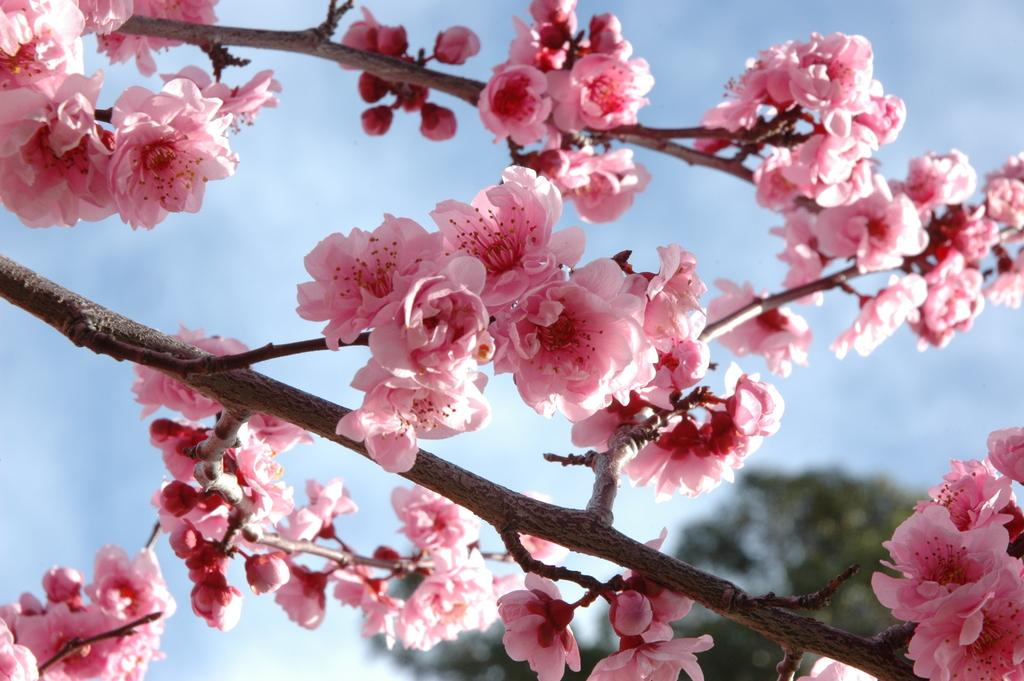What type of plants can be seen in the image? There are flowers in the image. What else can be seen in the image besides flowers? There are branches visible in the image. What is located in the background of the image? There is a tree and clouds in the sky visible in the background of the image. What type of flock is flying over the tree in the image? There is no flock visible in the image; only flowers, branches, a tree, and clouds in the sky are present. 